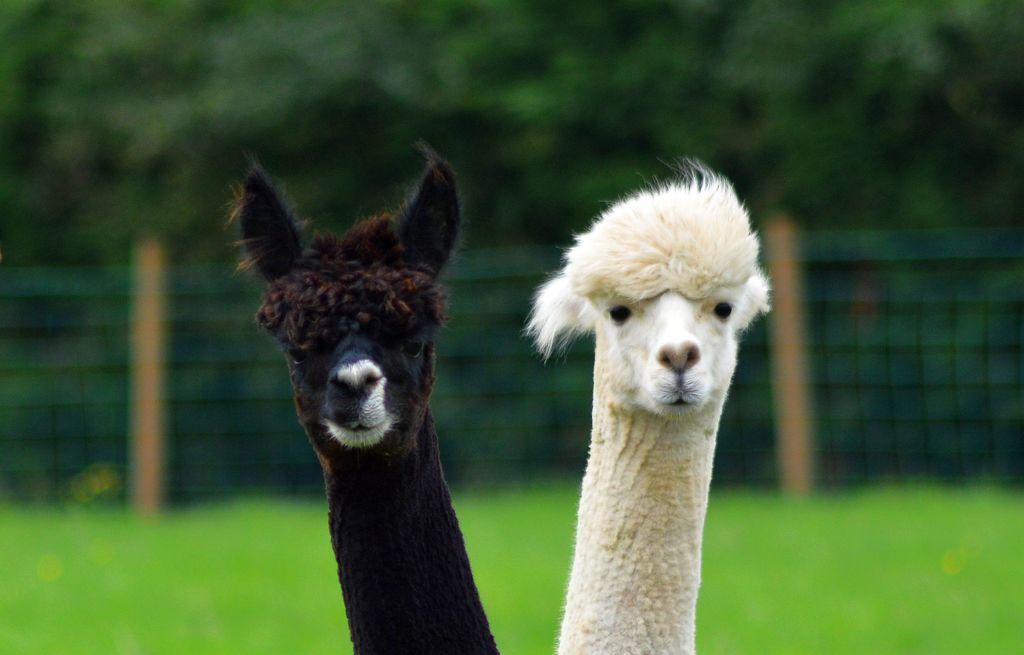How many animals are present in the image? There are two animals in the image. What are the colors of the animals? One animal is white, and the other is black. Can you describe the background of the image? The background of the image is blurry. What type of environment is depicted in the image? There is greenery visible in the image, suggesting a natural setting. What type of humor is being shared between the animals during their dinner in the image? There is no dinner or humor present in the image; it features two animals with different colors in a natural setting. What type of border is visible in the image? There is no border present in the image; it focuses on the two animals and the surrounding greenery. 